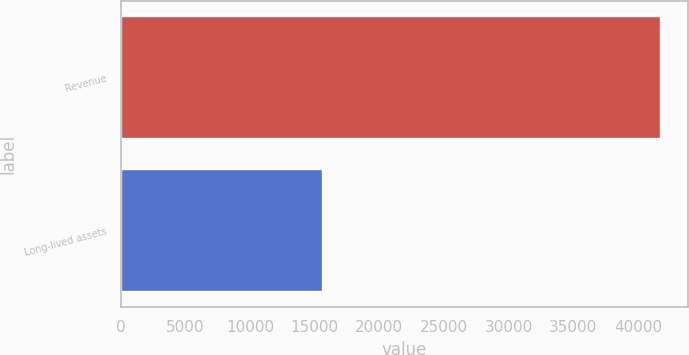<chart> <loc_0><loc_0><loc_500><loc_500><bar_chart><fcel>Revenue<fcel>Long-lived assets<nl><fcel>41772<fcel>15651<nl></chart> 